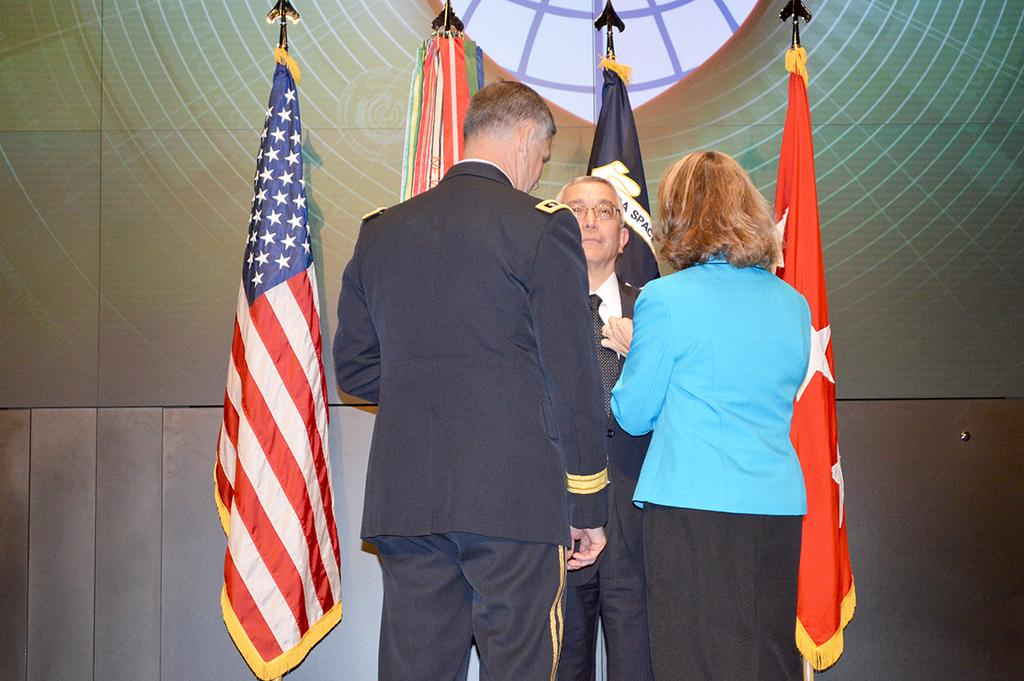How many people are in the image? There are three persons in the image. What is the man wearing in the image? The man is wearing a suit in the image. What can be seen in the background of the image? There are flags in the background of the image. What caption is written on the bottom of the image? There is no caption written on the bottom of the image. What type of selection is being made by the fireman in the image? There is no fireman present in the image. 